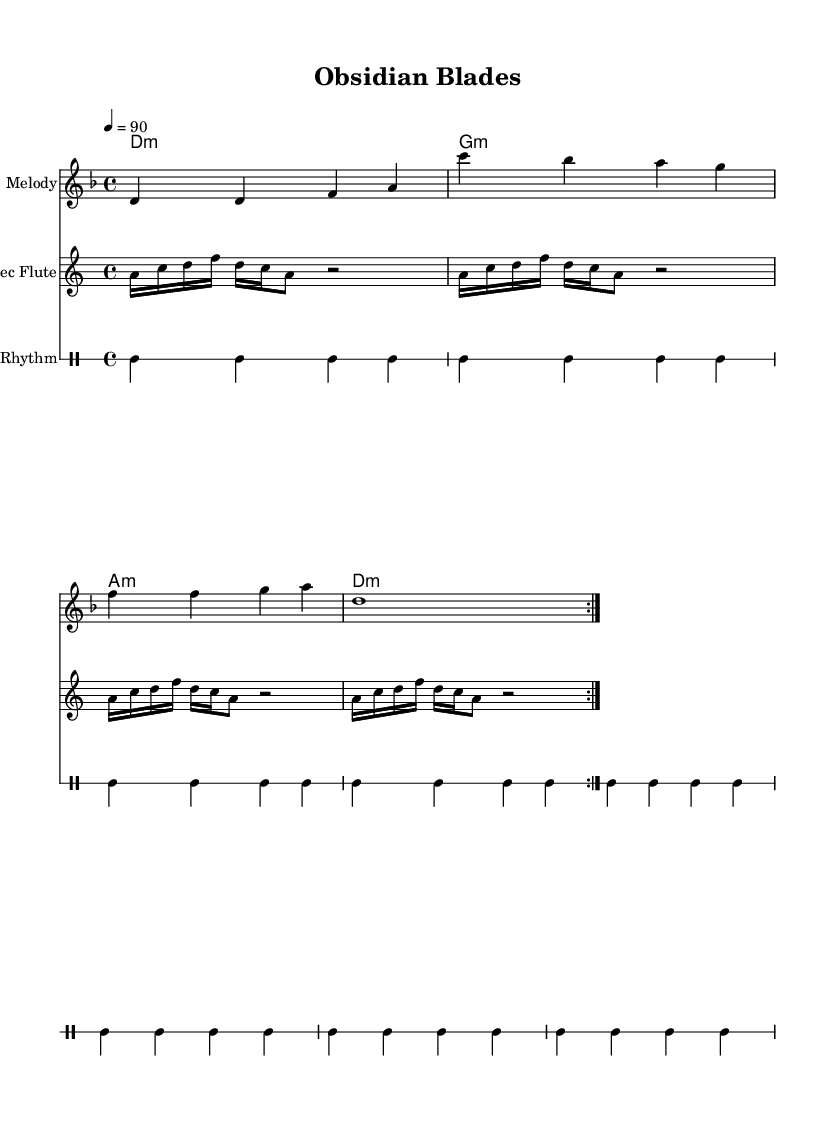What is the key signature of this music? The key signature is D minor, indicated by one flat (B♭) that appears in the key signature area.
Answer: D minor What is the time signature of this piece? The time signature is 4/4, which indicates that there are four beats in each measure and a quarter note receives one beat. This is found at the beginning of the score.
Answer: 4/4 What is the tempo marking for this composition? The tempo marking is 90 beats per minute, indicated at the start of the score with the text `4 = 90`. This informs how fast the piece should be played.
Answer: 90 How many times is the melody repeated? The melody is indicated to be repeated twice, as shown by the `\repeat volta 2` marking at the beginning of the melody section.
Answer: 2 What type of rhythm is predominantly used in the drum part? The predominant rhythm in the drum part is a combination of bass drums and hi-hats, which creates a hip-hop-style backbeat evident in the repeated patterns outlined in the drum staff.
Answer: Bass and hi-hat How many measures does the flute line have? The Aztec Flute line contains four measures, as it repeats the pattern four times as indicated by `\repeat unfold 4`.
Answer: 4 What instrument is described as "Aztec Flute"? The "Aztec Flute" is a specific instrument labeled in the score, representing a sound reminiscent of traditional Mesoamerican music intertwined with hip-hop elements.
Answer: Aztec Flute 